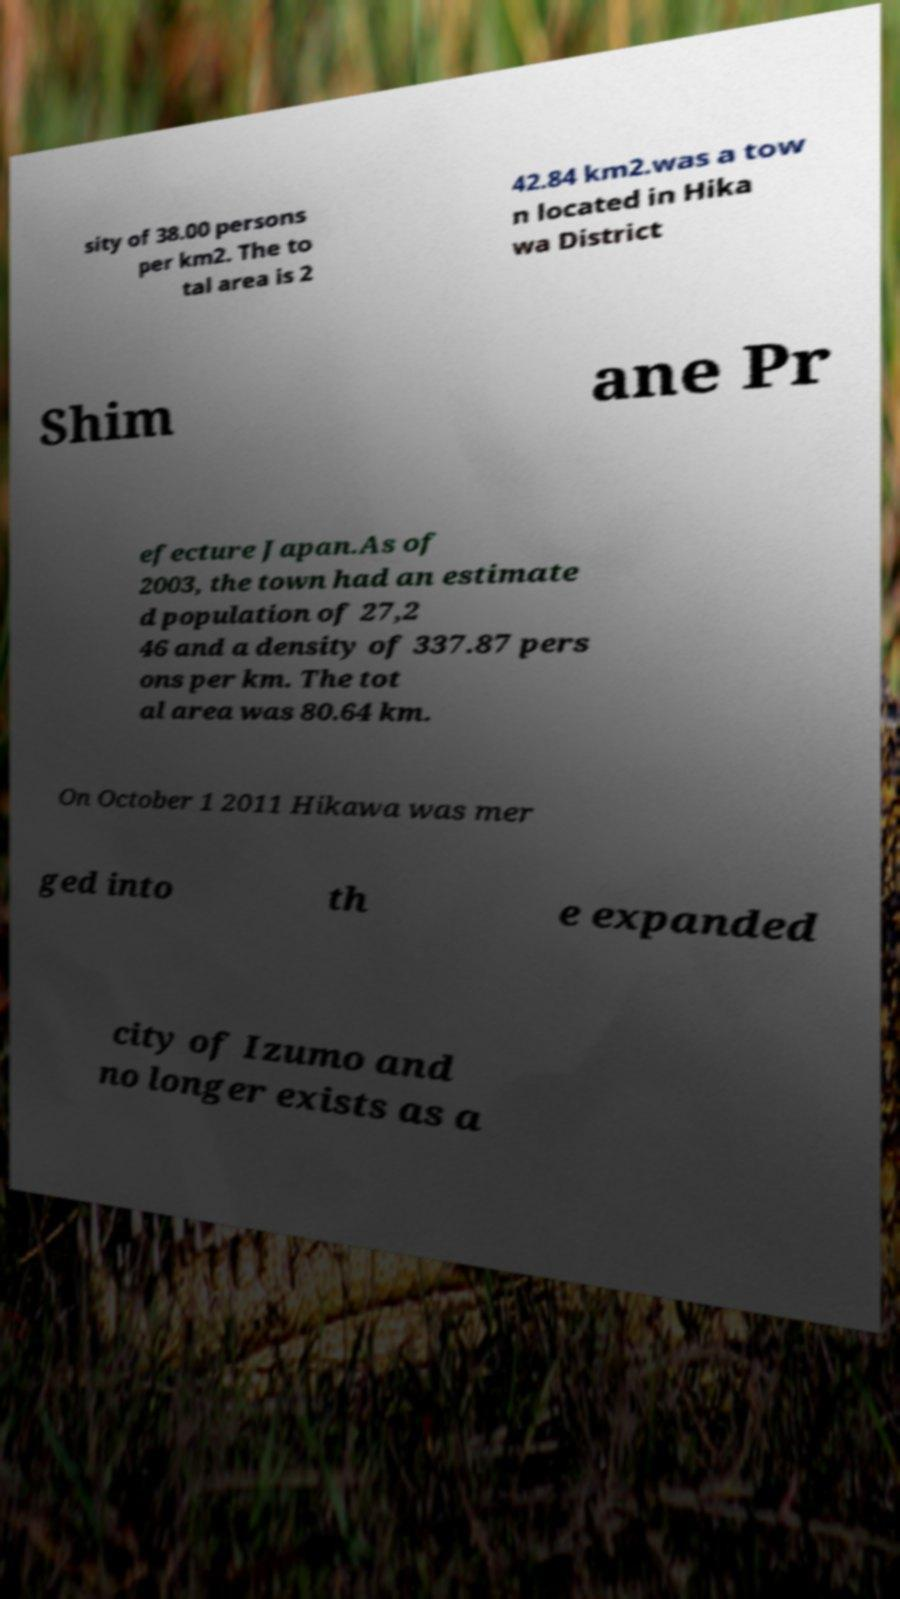Please read and relay the text visible in this image. What does it say? sity of 38.00 persons per km2. The to tal area is 2 42.84 km2.was a tow n located in Hika wa District Shim ane Pr efecture Japan.As of 2003, the town had an estimate d population of 27,2 46 and a density of 337.87 pers ons per km. The tot al area was 80.64 km. On October 1 2011 Hikawa was mer ged into th e expanded city of Izumo and no longer exists as a 